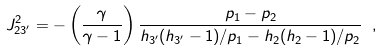Convert formula to latex. <formula><loc_0><loc_0><loc_500><loc_500>J ^ { 2 } _ { 2 3 ^ { \prime } } = - \left ( \frac { \gamma } { \gamma - 1 } \right ) \frac { p _ { 1 } - p _ { 2 } } { h _ { 3 ^ { \prime } } ( h _ { 3 ^ { \prime } } - 1 ) / p _ { 1 } - h _ { 2 } ( h _ { 2 } - 1 ) / p _ { 2 } } \ ,</formula> 